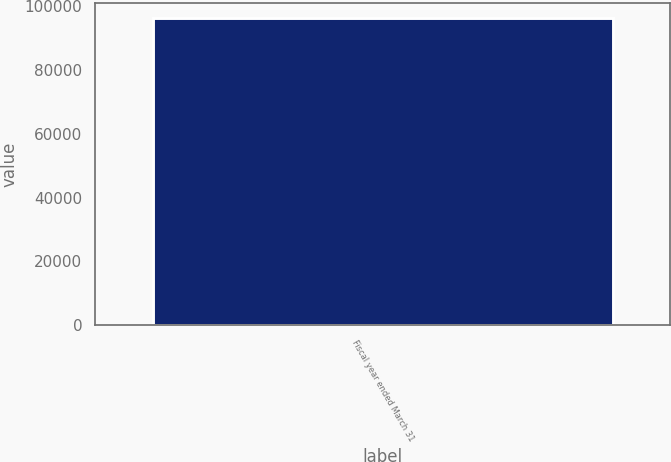Convert chart. <chart><loc_0><loc_0><loc_500><loc_500><bar_chart><fcel>Fiscal year ended March 31<nl><fcel>96249<nl></chart> 